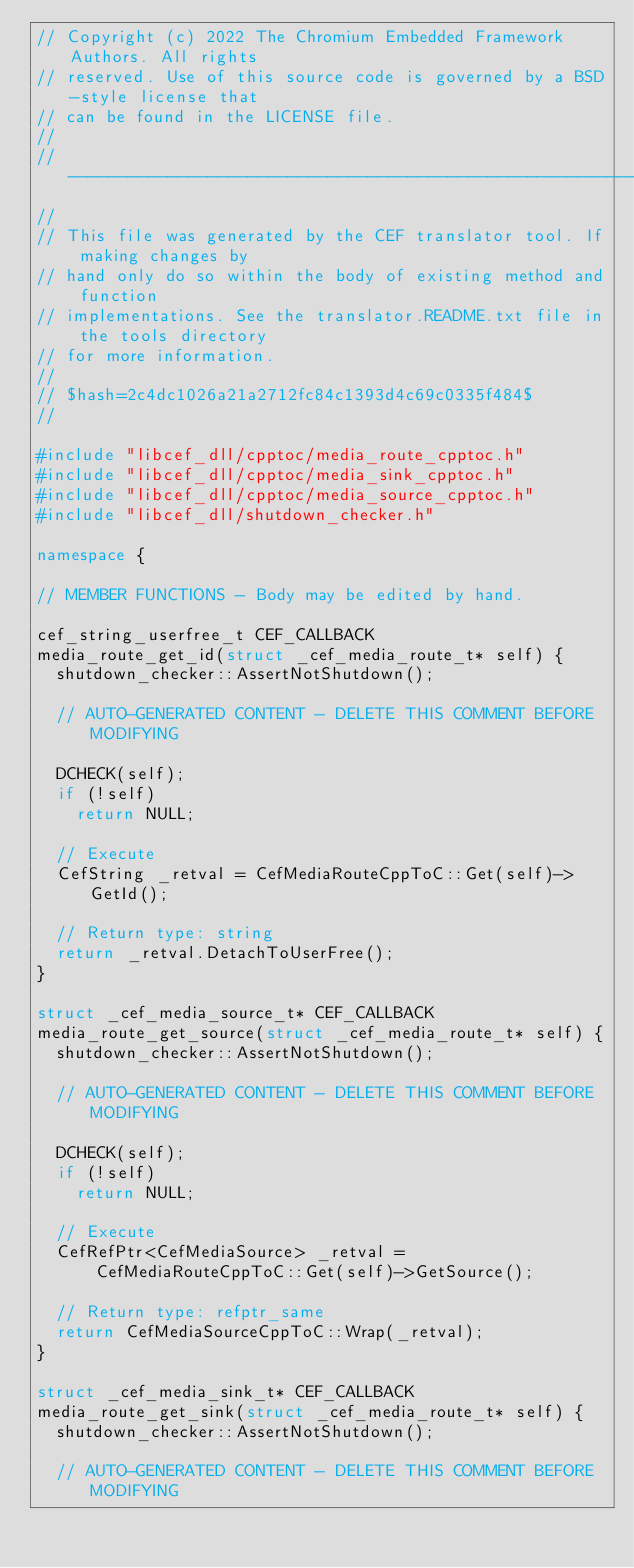Convert code to text. <code><loc_0><loc_0><loc_500><loc_500><_C++_>// Copyright (c) 2022 The Chromium Embedded Framework Authors. All rights
// reserved. Use of this source code is governed by a BSD-style license that
// can be found in the LICENSE file.
//
// ---------------------------------------------------------------------------
//
// This file was generated by the CEF translator tool. If making changes by
// hand only do so within the body of existing method and function
// implementations. See the translator.README.txt file in the tools directory
// for more information.
//
// $hash=2c4dc1026a21a2712fc84c1393d4c69c0335f484$
//

#include "libcef_dll/cpptoc/media_route_cpptoc.h"
#include "libcef_dll/cpptoc/media_sink_cpptoc.h"
#include "libcef_dll/cpptoc/media_source_cpptoc.h"
#include "libcef_dll/shutdown_checker.h"

namespace {

// MEMBER FUNCTIONS - Body may be edited by hand.

cef_string_userfree_t CEF_CALLBACK
media_route_get_id(struct _cef_media_route_t* self) {
  shutdown_checker::AssertNotShutdown();

  // AUTO-GENERATED CONTENT - DELETE THIS COMMENT BEFORE MODIFYING

  DCHECK(self);
  if (!self)
    return NULL;

  // Execute
  CefString _retval = CefMediaRouteCppToC::Get(self)->GetId();

  // Return type: string
  return _retval.DetachToUserFree();
}

struct _cef_media_source_t* CEF_CALLBACK
media_route_get_source(struct _cef_media_route_t* self) {
  shutdown_checker::AssertNotShutdown();

  // AUTO-GENERATED CONTENT - DELETE THIS COMMENT BEFORE MODIFYING

  DCHECK(self);
  if (!self)
    return NULL;

  // Execute
  CefRefPtr<CefMediaSource> _retval =
      CefMediaRouteCppToC::Get(self)->GetSource();

  // Return type: refptr_same
  return CefMediaSourceCppToC::Wrap(_retval);
}

struct _cef_media_sink_t* CEF_CALLBACK
media_route_get_sink(struct _cef_media_route_t* self) {
  shutdown_checker::AssertNotShutdown();

  // AUTO-GENERATED CONTENT - DELETE THIS COMMENT BEFORE MODIFYING
</code> 